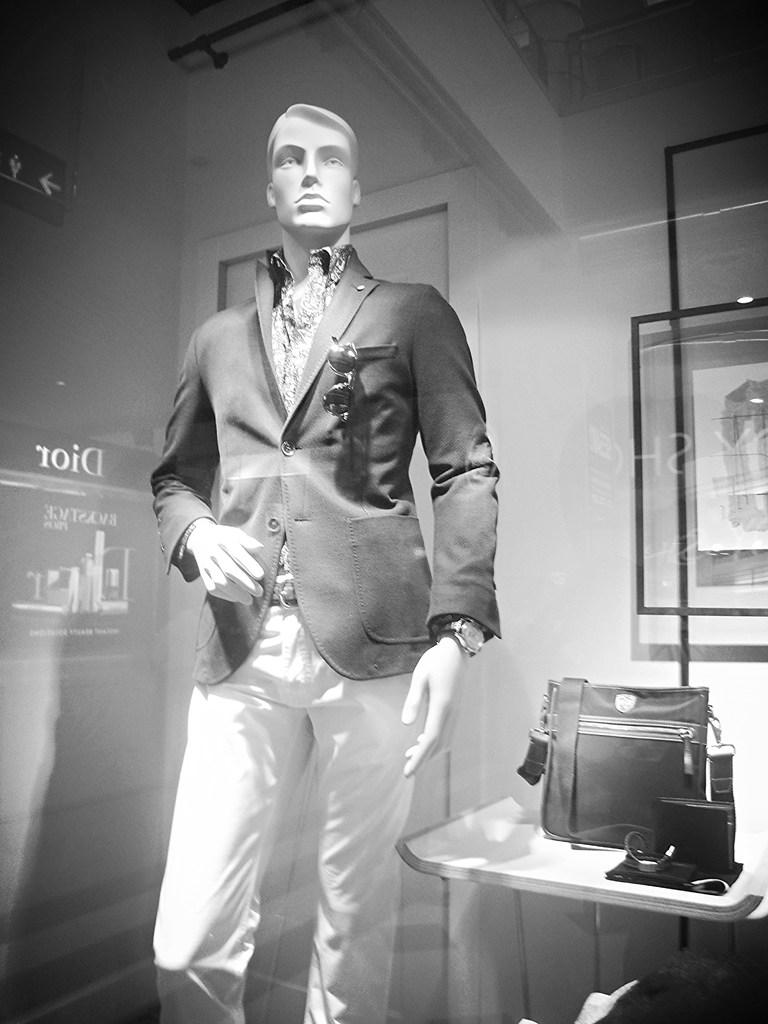What is the main object in the image? There is a mannequin in the image. What accessory is visible in the image? There are spectacles in the image. What type of item is present on the table in the image? There is a bag on the table in the image. Can you describe any other objects on the table in the image? There are other things on the table in the image, but their specific details are not mentioned in the provided facts. What type of meal is being prepared on the table in the image? There is no meal being prepared in the image; it features a mannequin, spectacles, a bag, and other unspecified objects on the table. How many horses are visible in the image? There are no horses present in the image. 